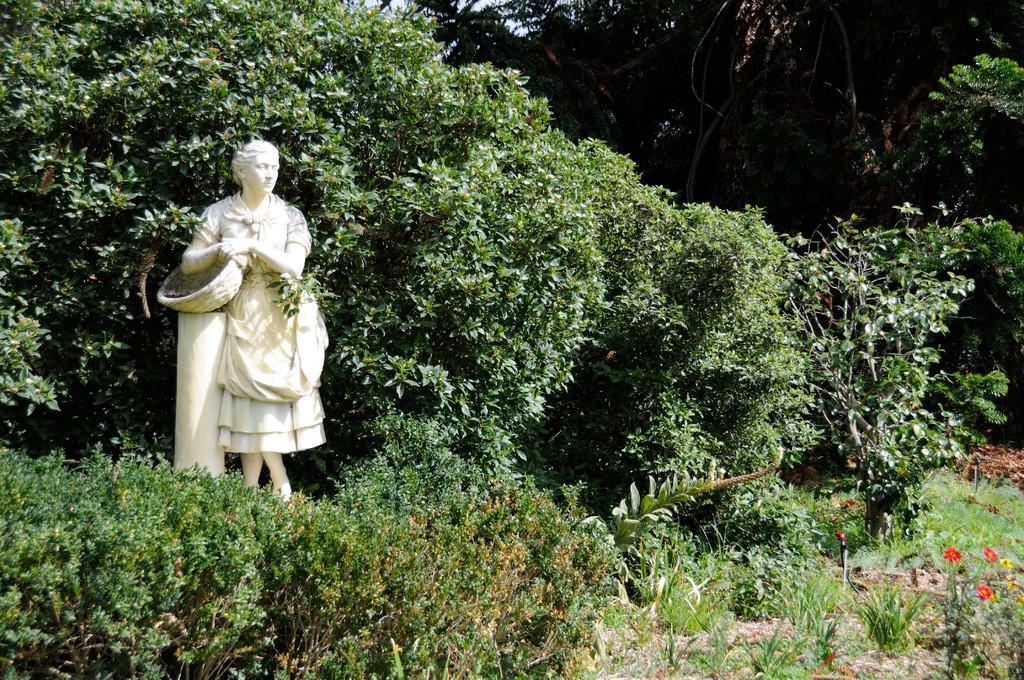Describe this image in one or two sentences. At the bottom there are many plants. On the left side there is a statue of a person. In the background there are many trees. 